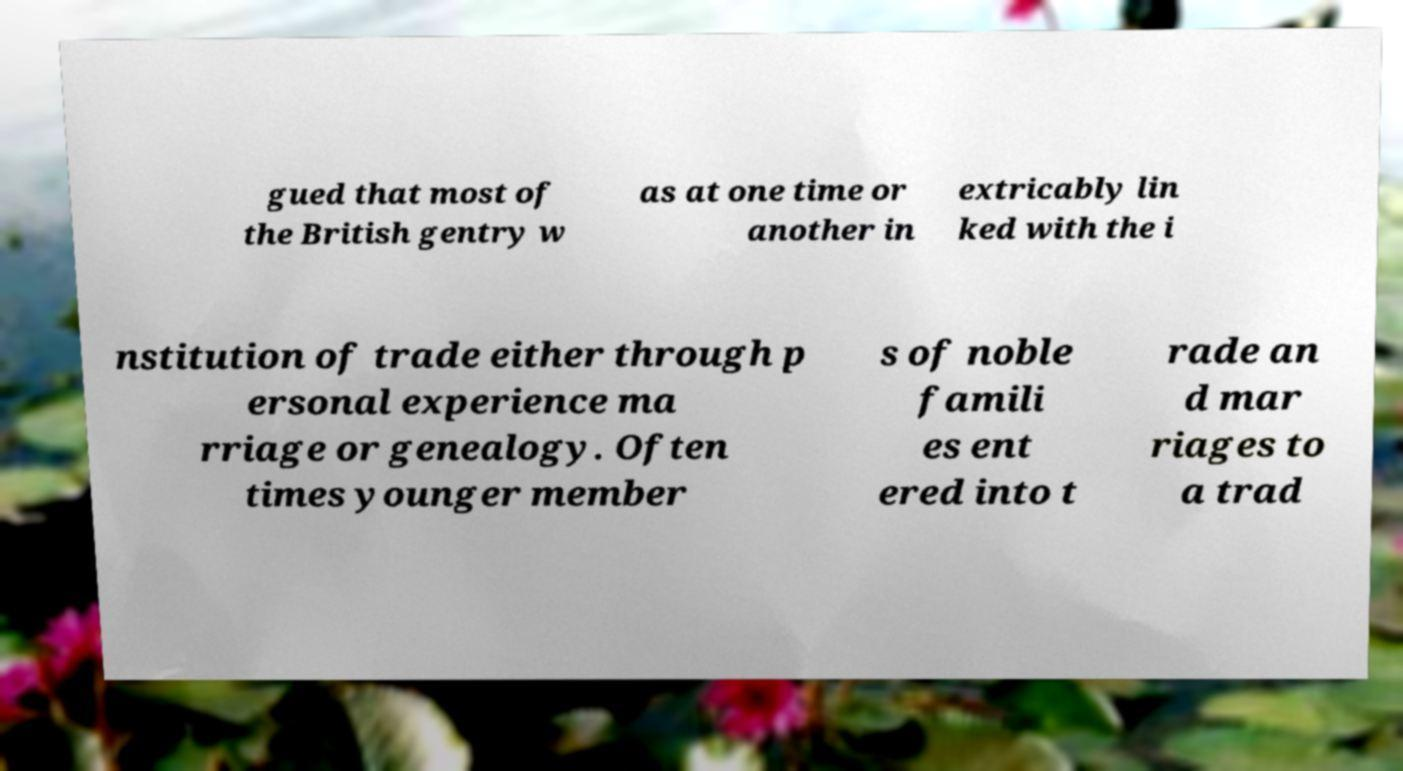What messages or text are displayed in this image? I need them in a readable, typed format. gued that most of the British gentry w as at one time or another in extricably lin ked with the i nstitution of trade either through p ersonal experience ma rriage or genealogy. Often times younger member s of noble famili es ent ered into t rade an d mar riages to a trad 